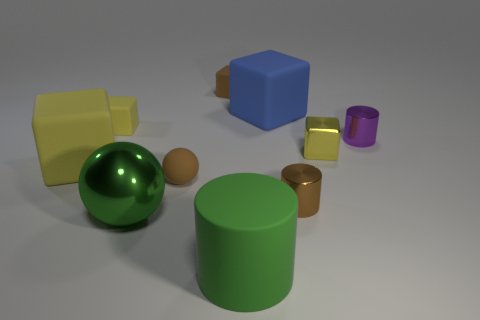Subtract all cyan cylinders. How many yellow cubes are left? 3 Subtract all brown cubes. How many cubes are left? 4 Subtract all brown blocks. How many blocks are left? 4 Subtract all green cylinders. Subtract all cyan balls. How many cylinders are left? 2 Subtract all spheres. How many objects are left? 8 Add 7 green things. How many green things exist? 9 Subtract 0 red cylinders. How many objects are left? 10 Subtract all brown metallic things. Subtract all brown shiny things. How many objects are left? 8 Add 6 shiny objects. How many shiny objects are left? 10 